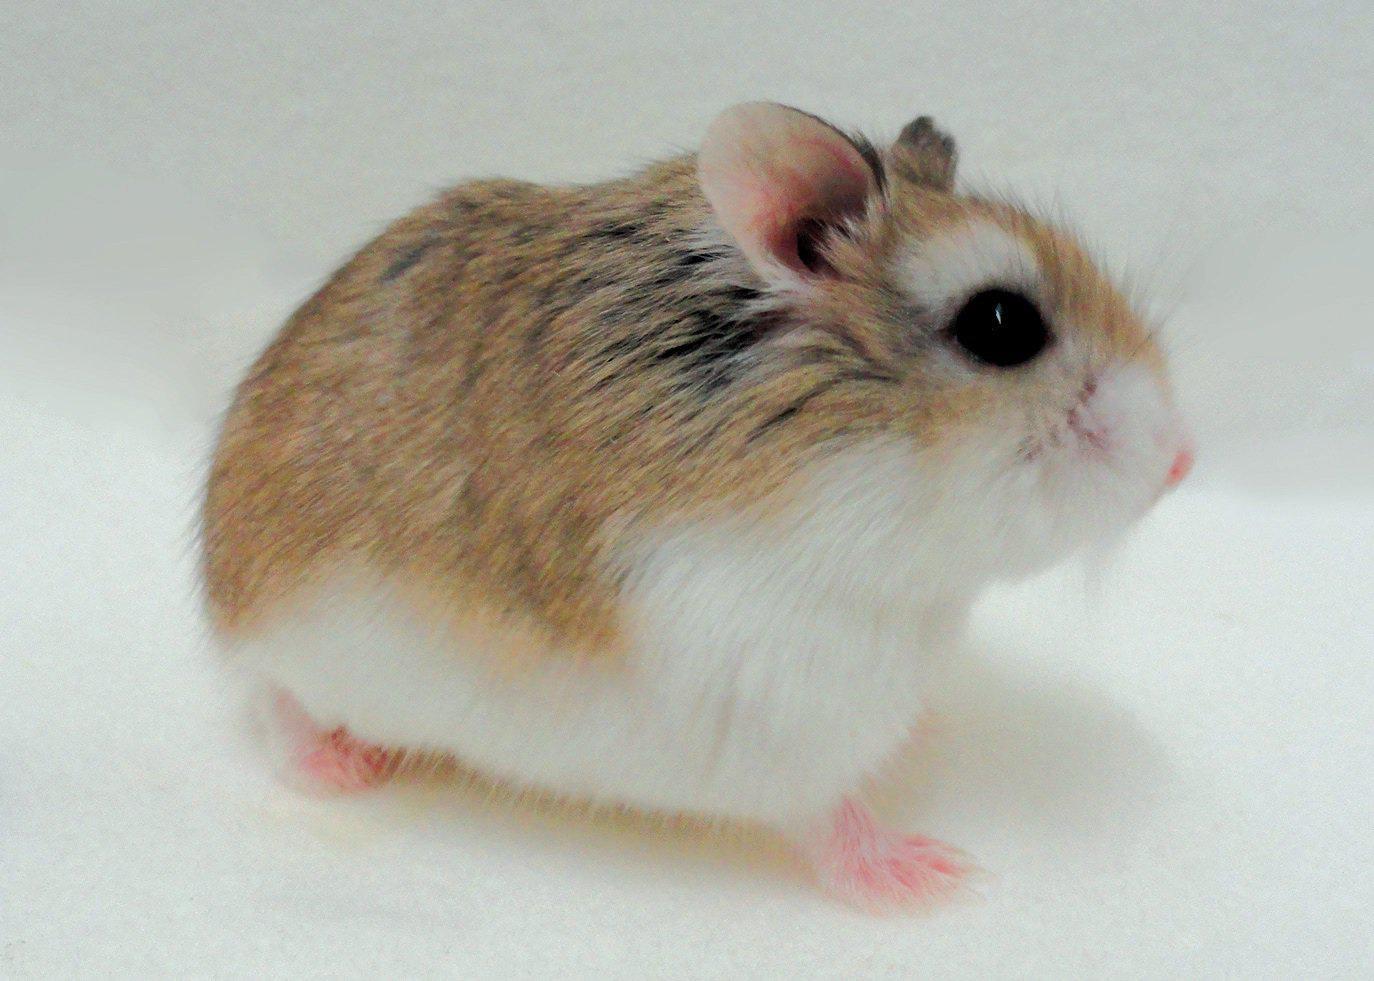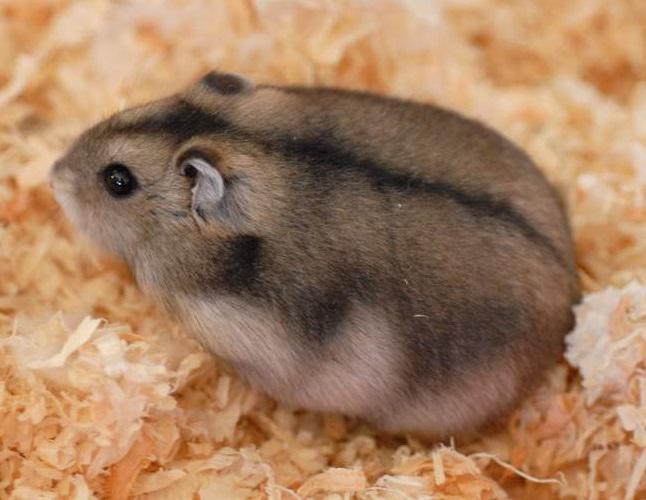The first image is the image on the left, the second image is the image on the right. Assess this claim about the two images: "One image shows a hand holding more than one small rodent.". Correct or not? Answer yes or no. No. The first image is the image on the left, the second image is the image on the right. Considering the images on both sides, is "A human hand is holding some hamsters." valid? Answer yes or no. No. 